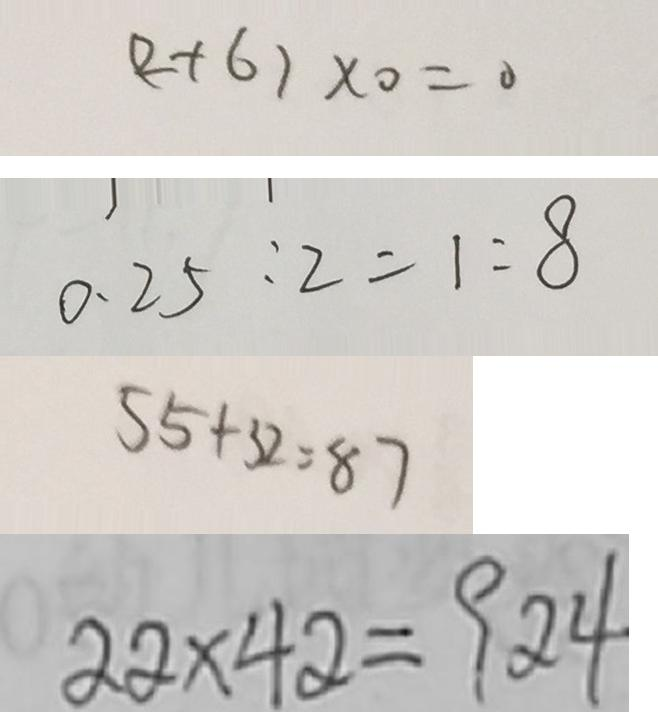Convert formula to latex. <formula><loc_0><loc_0><loc_500><loc_500>( 2 + 6 ) \times 0 = 0 
 0 . 2 5 : 2 = 1 : 8 
 5 5 + 3 2 = 8 7 
 2 2 \times 4 2 = 9 2 4</formula> 